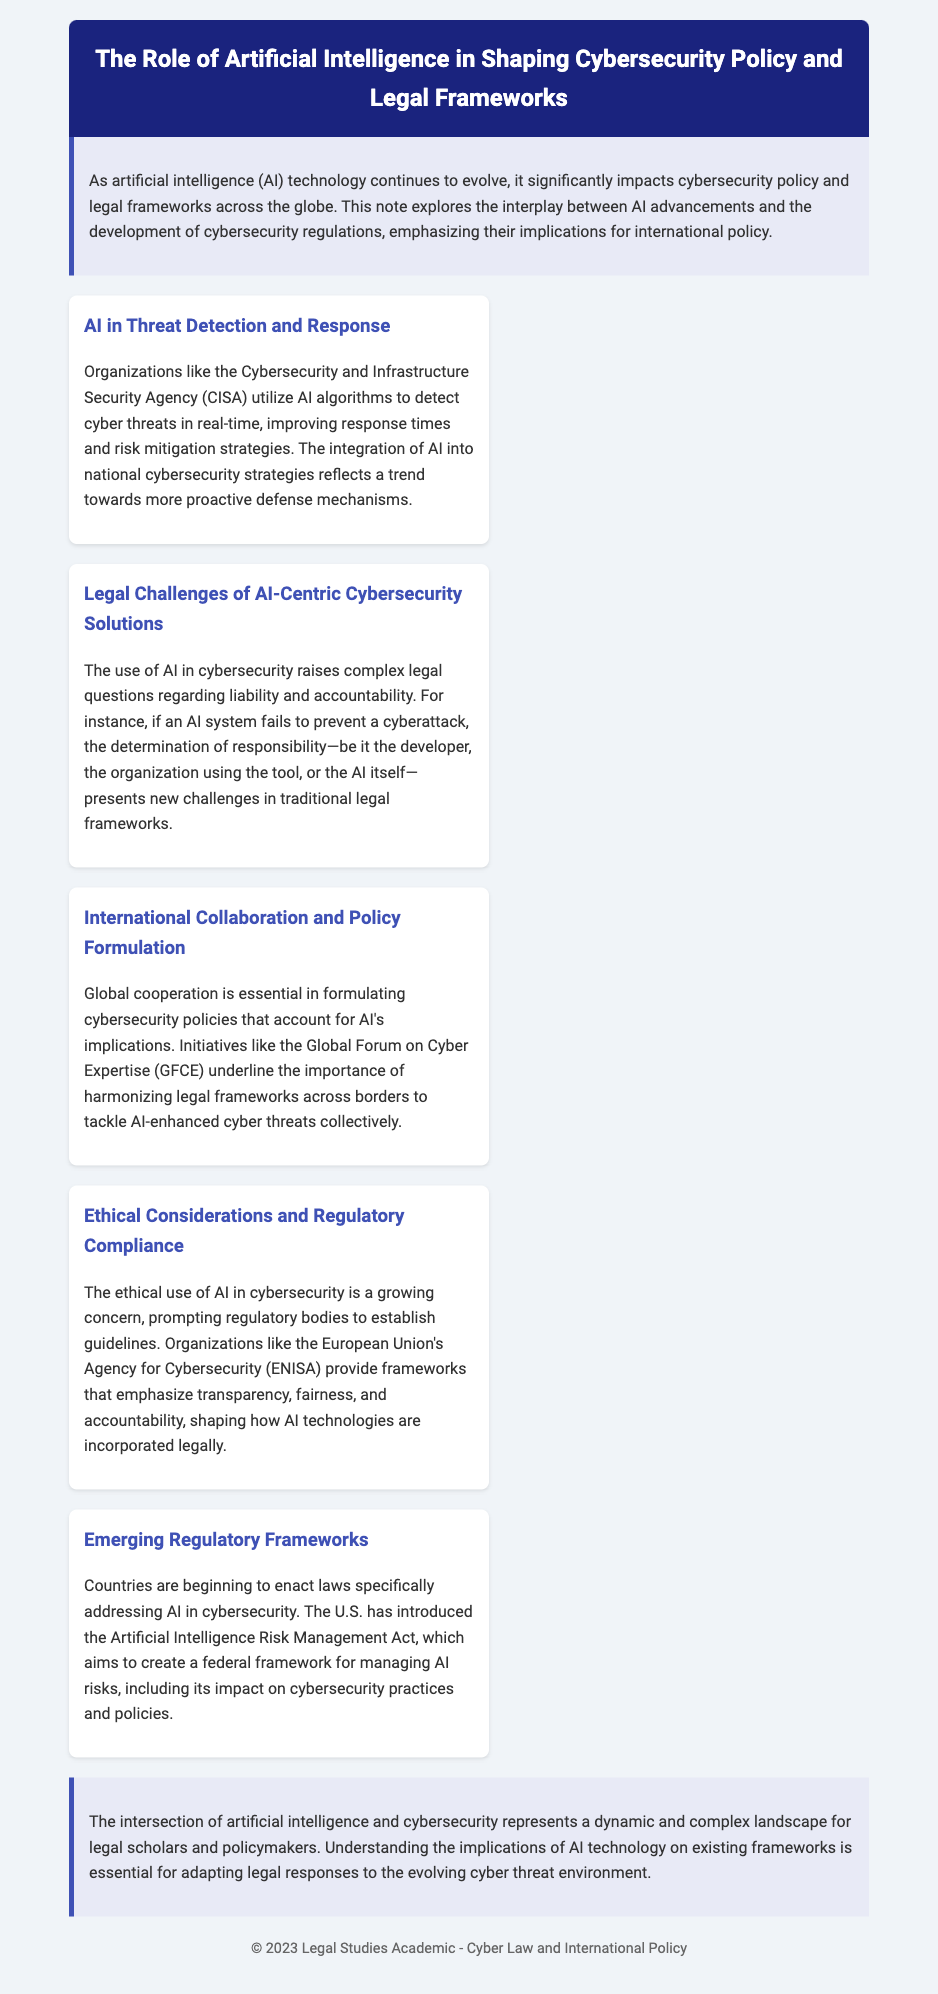What organization uses AI algorithms for threat detection? The document states that the Cybersecurity and Infrastructure Security Agency (CISA) utilizes AI algorithms for this purpose.
Answer: CISA What is a key challenge posed by AI in cybersecurity? The document mentions the determination of responsibility as a complex legal question raised by AI's use in cybersecurity.
Answer: Responsibility What international initiative emphasizes global cooperation in cybersecurity policy? The text highlights the Global Forum on Cyber Expertise (GFCE) as an important initiative in this context.
Answer: GFCE What ethical aspects are emphasized by regulatory bodies regarding AI usage? The document points out transparency, fairness, and accountability as key ethical considerations promoted by regulatory frameworks.
Answer: Transparency, fairness, accountability What legislation has the U.S. introduced concerning AI in cybersecurity? The document refers to the Artificial Intelligence Risk Management Act as the relevant legislation aimed at managing AI risks.
Answer: Artificial Intelligence Risk Management Act How does the use of AI in cybersecurity reflect on national strategies? According to the document, the integration of AI into national cybersecurity strategies reflects a trend towards more proactive defense mechanisms.
Answer: Proactive defense mechanisms Which organization provides guidelines for the ethical use of AI in cybersecurity? The document mentions the European Union's Agency for Cybersecurity (ENISA) as an organization providing such frameworks.
Answer: ENISA What is the overall theme of the document? The document discusses the impact of artificial intelligence on cybersecurity policy and legal frameworks.
Answer: AI's impact on cybersecurity policy 